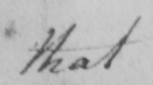What does this handwritten line say? that 